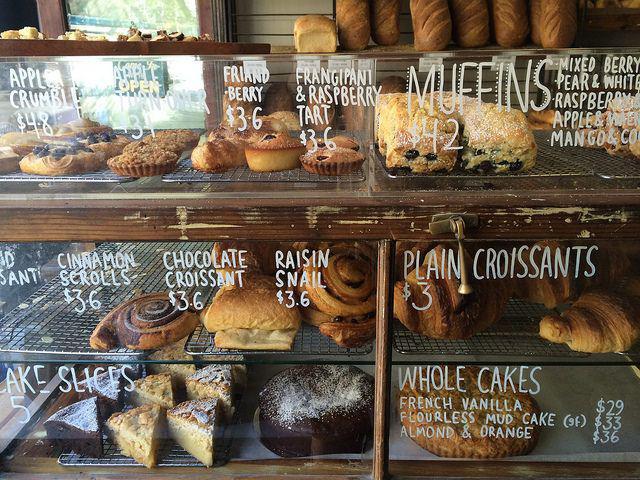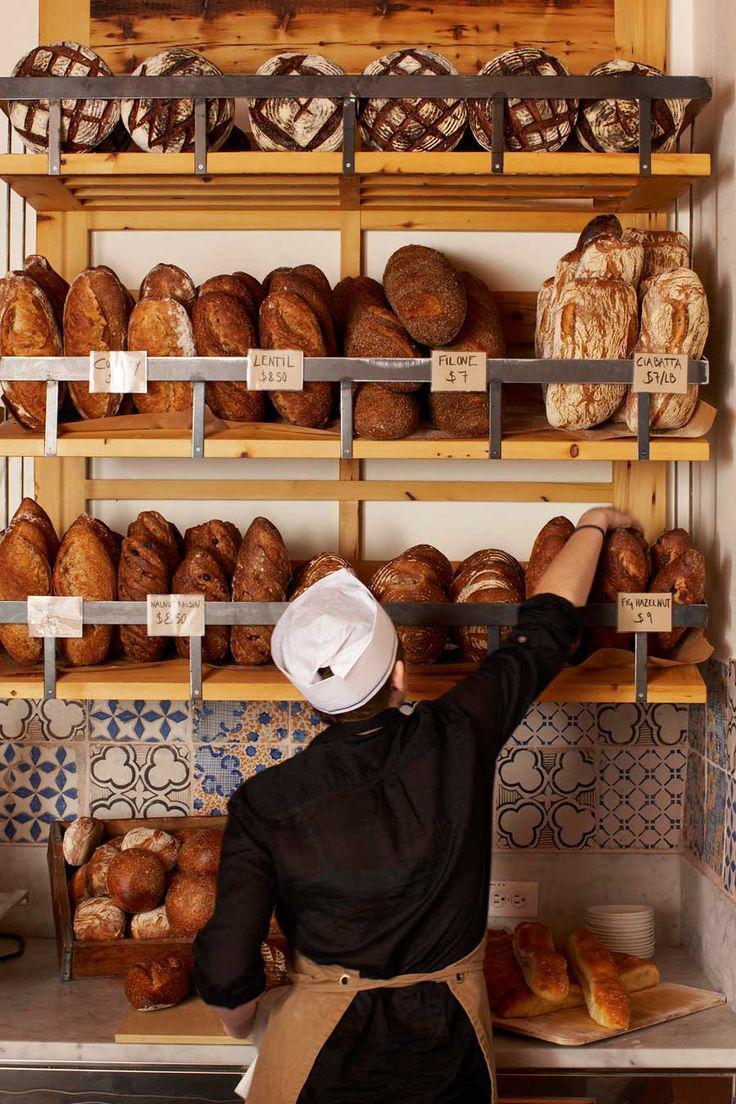The first image is the image on the left, the second image is the image on the right. Considering the images on both sides, is "There are at least five hanging lights in the image on the right." valid? Answer yes or no. No. 